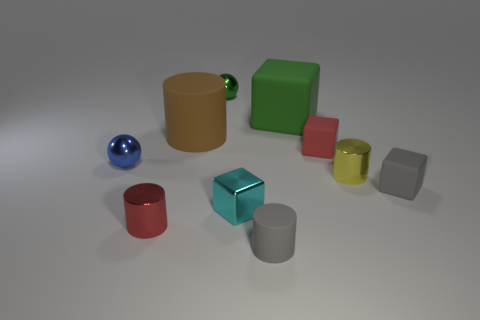Which objects in the picture could hold water? The objects that could potentially hold water in this image appear to be the red cup and the gold cup due to their open tops and container-like shapes. 